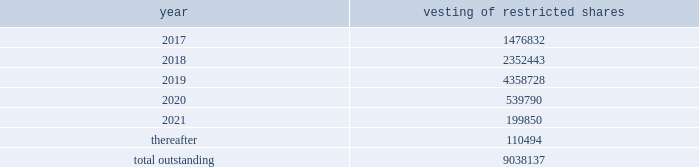The intrinsic value of restricted stock awards vested during the years ended december 31 , 2016 , 2015 and 2014 was $ 25 million , $ 31 million and $ 17 million , respectively .
Restricted stock awards made to employees have vesting periods ranging from 1 year with variable vesting dates to 10 years .
Following is a summary of the future vesting of our outstanding restricted stock awards : vesting of restricted shares .
The related compensation costs less estimated forfeitures is generally recognized ratably over the vesting period of the restricted stock awards .
Upon vesting , the grants will be paid in our class p common shares .
During 2016 , 2015 and 2014 , we recorded $ 66 million , $ 52 million and $ 51 million , respectively , in expense related to restricted stock awards and capitalized approximately $ 9 million , $ 15 million and $ 6 million , respectively .
At december 31 , 2016 and 2015 , unrecognized restricted stock awards compensation costs , less estimated forfeitures , was approximately $ 133 million and $ 154 million , respectively .
Pension and other postretirement benefit plans savings plan we maintain a defined contribution plan covering eligible u.s .
Employees .
We contribute 5% ( 5 % ) of eligible compensation for most of the plan participants .
Certain plan participants 2019 contributions and company contributions are based on collective bargaining agreements .
The total expense for our savings plan was approximately $ 48 million , $ 46 million , and $ 42 million for the years ended december 31 , 2016 , 2015 and 2014 , respectively .
Pension plans our u.s .
Pension plan is a defined benefit plan that covers substantially all of our u.s .
Employees and provides benefits under a cash balance formula .
A participant in the cash balance plan accrues benefits through contribution credits based on a combination of age and years of service , times eligible compensation .
Interest is also credited to the participant 2019s plan account .
A participant becomes fully vested in the plan after three years , and may take a lump sum distribution upon termination of employment or retirement .
Certain collectively bargained and grandfathered employees continue to accrue benefits through career pay or final pay formulas .
Two of our subsidiaries , kinder morgan canada inc .
And trans mountain pipeline inc .
( as general partner of trans mountain pipeline l.p. ) , are sponsors of pension plans for eligible canadian and trans mountain pipeline employees .
The plans include registered defined benefit pension plans , supplemental unfunded arrangements ( which provide pension benefits in excess of statutory limits ) and defined contributory plans .
Benefits under the defined benefit components accrue through career pay or final pay formulas .
The net periodic benefit costs , contributions and liability amounts associated with our canadian plans are not material to our consolidated income statements or balance sheets ; however , we began to include the activity and balances associated with our canadian plans ( including our canadian opeb plans discussed below ) in the following disclosures on a prospective basis beginning in 2016 .
The associated net periodic benefit costs for these combined canadian plans of $ 12 million and $ 10 million for the years ended december 31 , 2015 and 2014 , respectively , were reported separately in prior years .
Other postretirement benefit plans we and certain of our u.s .
Subsidiaries provide other postretirement benefits ( opeb ) , including medical benefits for closed groups of retired employees and certain grandfathered employees and their dependents , and limited postretirement life insurance benefits for retired employees .
Our canadian subsidiaries also provide opeb benefits to current and future retirees and their dependents .
Medical benefits under these opeb plans may be subject to deductibles , co-payment provisions , dollar .
What percentage of restricted shares vest in 2018? 
Computations: (2352443 / 9038137)
Answer: 0.26028. 